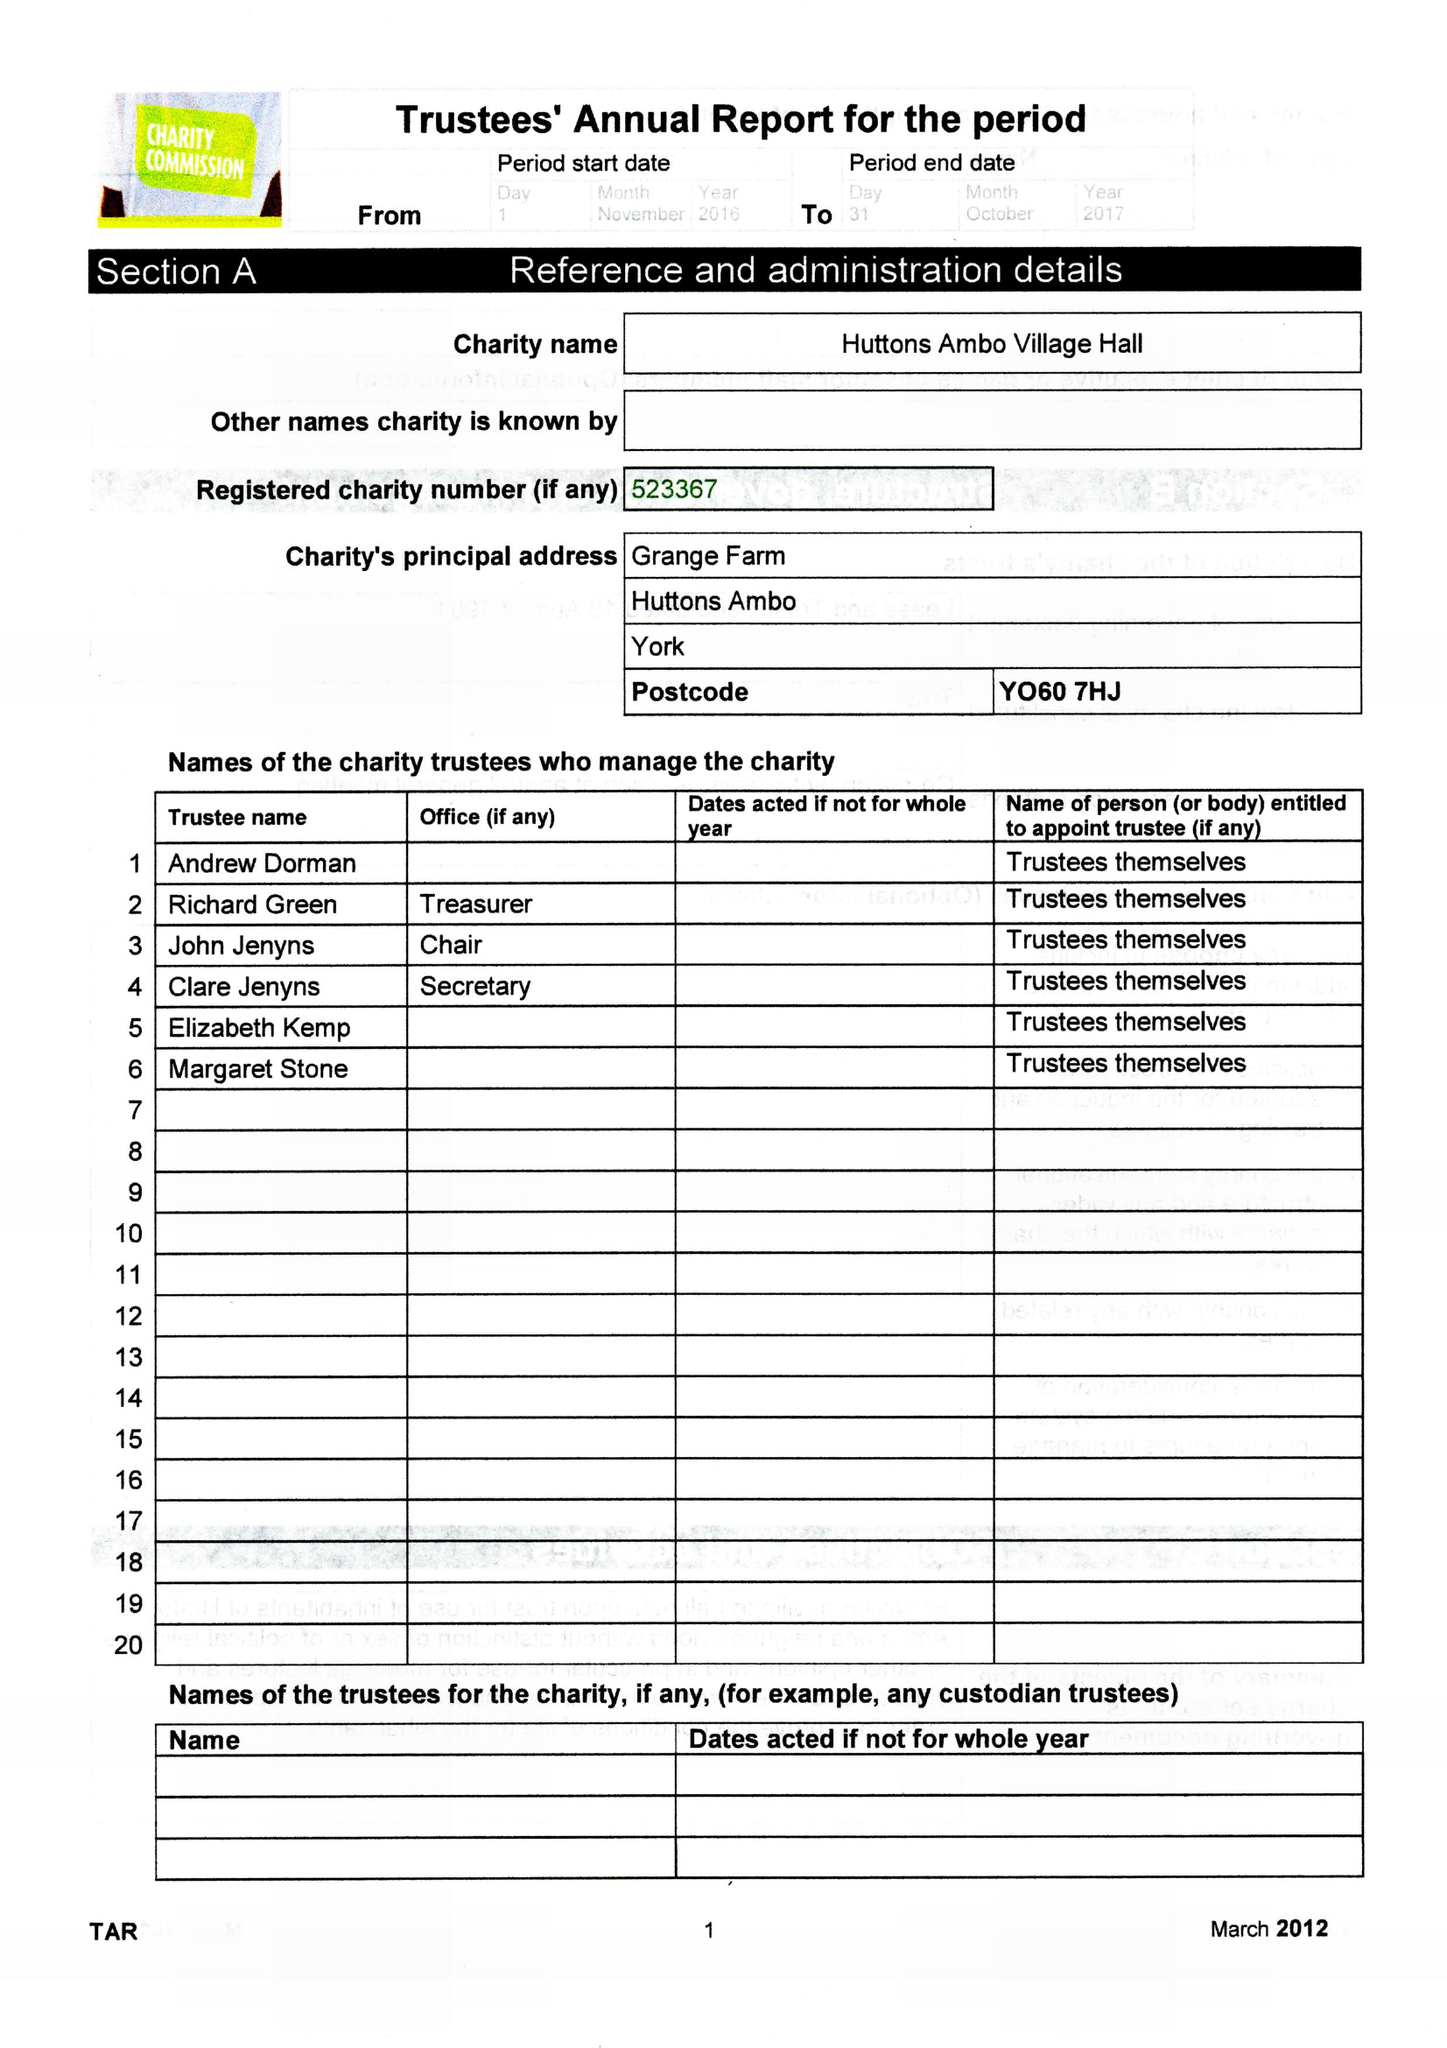What is the value for the report_date?
Answer the question using a single word or phrase. 2017-10-31 